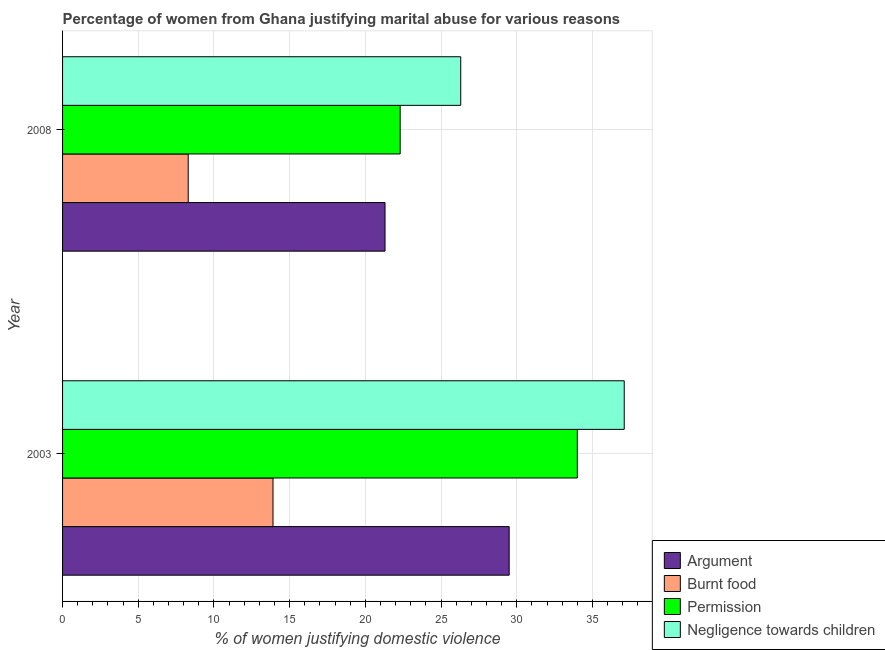How many different coloured bars are there?
Your answer should be compact. 4. How many groups of bars are there?
Provide a succinct answer. 2. Are the number of bars per tick equal to the number of legend labels?
Give a very brief answer. Yes. Are the number of bars on each tick of the Y-axis equal?
Provide a short and direct response. Yes. How many bars are there on the 1st tick from the bottom?
Make the answer very short. 4. In how many cases, is the number of bars for a given year not equal to the number of legend labels?
Offer a very short reply. 0. What is the percentage of women justifying abuse for showing negligence towards children in 2003?
Provide a succinct answer. 37.1. Across all years, what is the maximum percentage of women justifying abuse in the case of an argument?
Make the answer very short. 29.5. Across all years, what is the minimum percentage of women justifying abuse for showing negligence towards children?
Offer a terse response. 26.3. What is the total percentage of women justifying abuse for burning food in the graph?
Give a very brief answer. 22.2. What is the difference between the percentage of women justifying abuse for showing negligence towards children in 2003 and the percentage of women justifying abuse for going without permission in 2008?
Keep it short and to the point. 14.8. What is the average percentage of women justifying abuse for showing negligence towards children per year?
Offer a very short reply. 31.7. In the year 2003, what is the difference between the percentage of women justifying abuse for burning food and percentage of women justifying abuse for going without permission?
Your answer should be compact. -20.1. What is the ratio of the percentage of women justifying abuse for burning food in 2003 to that in 2008?
Offer a terse response. 1.68. What does the 3rd bar from the top in 2003 represents?
Your answer should be very brief. Burnt food. What does the 1st bar from the bottom in 2003 represents?
Your answer should be compact. Argument. How many bars are there?
Offer a very short reply. 8. What is the difference between two consecutive major ticks on the X-axis?
Offer a terse response. 5. Where does the legend appear in the graph?
Your response must be concise. Bottom right. How are the legend labels stacked?
Your response must be concise. Vertical. What is the title of the graph?
Your answer should be compact. Percentage of women from Ghana justifying marital abuse for various reasons. Does "Quality of logistic services" appear as one of the legend labels in the graph?
Keep it short and to the point. No. What is the label or title of the X-axis?
Provide a succinct answer. % of women justifying domestic violence. What is the label or title of the Y-axis?
Make the answer very short. Year. What is the % of women justifying domestic violence of Argument in 2003?
Your answer should be very brief. 29.5. What is the % of women justifying domestic violence in Negligence towards children in 2003?
Your answer should be compact. 37.1. What is the % of women justifying domestic violence in Argument in 2008?
Ensure brevity in your answer.  21.3. What is the % of women justifying domestic violence of Burnt food in 2008?
Provide a short and direct response. 8.3. What is the % of women justifying domestic violence of Permission in 2008?
Your answer should be very brief. 22.3. What is the % of women justifying domestic violence in Negligence towards children in 2008?
Your answer should be compact. 26.3. Across all years, what is the maximum % of women justifying domestic violence in Argument?
Give a very brief answer. 29.5. Across all years, what is the maximum % of women justifying domestic violence in Burnt food?
Provide a short and direct response. 13.9. Across all years, what is the maximum % of women justifying domestic violence in Permission?
Your answer should be compact. 34. Across all years, what is the maximum % of women justifying domestic violence of Negligence towards children?
Your answer should be compact. 37.1. Across all years, what is the minimum % of women justifying domestic violence of Argument?
Ensure brevity in your answer.  21.3. Across all years, what is the minimum % of women justifying domestic violence of Burnt food?
Keep it short and to the point. 8.3. Across all years, what is the minimum % of women justifying domestic violence of Permission?
Your answer should be compact. 22.3. Across all years, what is the minimum % of women justifying domestic violence of Negligence towards children?
Your answer should be compact. 26.3. What is the total % of women justifying domestic violence in Argument in the graph?
Give a very brief answer. 50.8. What is the total % of women justifying domestic violence in Burnt food in the graph?
Your answer should be very brief. 22.2. What is the total % of women justifying domestic violence of Permission in the graph?
Offer a very short reply. 56.3. What is the total % of women justifying domestic violence of Negligence towards children in the graph?
Your answer should be very brief. 63.4. What is the difference between the % of women justifying domestic violence in Burnt food in 2003 and that in 2008?
Your answer should be very brief. 5.6. What is the difference between the % of women justifying domestic violence in Negligence towards children in 2003 and that in 2008?
Offer a very short reply. 10.8. What is the difference between the % of women justifying domestic violence of Argument in 2003 and the % of women justifying domestic violence of Burnt food in 2008?
Provide a short and direct response. 21.2. What is the difference between the % of women justifying domestic violence of Argument in 2003 and the % of women justifying domestic violence of Negligence towards children in 2008?
Provide a short and direct response. 3.2. What is the difference between the % of women justifying domestic violence in Burnt food in 2003 and the % of women justifying domestic violence in Permission in 2008?
Keep it short and to the point. -8.4. What is the difference between the % of women justifying domestic violence of Burnt food in 2003 and the % of women justifying domestic violence of Negligence towards children in 2008?
Make the answer very short. -12.4. What is the difference between the % of women justifying domestic violence in Permission in 2003 and the % of women justifying domestic violence in Negligence towards children in 2008?
Give a very brief answer. 7.7. What is the average % of women justifying domestic violence in Argument per year?
Give a very brief answer. 25.4. What is the average % of women justifying domestic violence of Permission per year?
Provide a succinct answer. 28.15. What is the average % of women justifying domestic violence in Negligence towards children per year?
Keep it short and to the point. 31.7. In the year 2003, what is the difference between the % of women justifying domestic violence of Argument and % of women justifying domestic violence of Burnt food?
Provide a succinct answer. 15.6. In the year 2003, what is the difference between the % of women justifying domestic violence in Burnt food and % of women justifying domestic violence in Permission?
Your answer should be compact. -20.1. In the year 2003, what is the difference between the % of women justifying domestic violence of Burnt food and % of women justifying domestic violence of Negligence towards children?
Your answer should be very brief. -23.2. In the year 2003, what is the difference between the % of women justifying domestic violence of Permission and % of women justifying domestic violence of Negligence towards children?
Give a very brief answer. -3.1. In the year 2008, what is the difference between the % of women justifying domestic violence of Argument and % of women justifying domestic violence of Permission?
Keep it short and to the point. -1. In the year 2008, what is the difference between the % of women justifying domestic violence of Argument and % of women justifying domestic violence of Negligence towards children?
Offer a terse response. -5. In the year 2008, what is the difference between the % of women justifying domestic violence in Burnt food and % of women justifying domestic violence in Permission?
Provide a short and direct response. -14. In the year 2008, what is the difference between the % of women justifying domestic violence of Burnt food and % of women justifying domestic violence of Negligence towards children?
Your response must be concise. -18. What is the ratio of the % of women justifying domestic violence of Argument in 2003 to that in 2008?
Offer a terse response. 1.39. What is the ratio of the % of women justifying domestic violence in Burnt food in 2003 to that in 2008?
Keep it short and to the point. 1.67. What is the ratio of the % of women justifying domestic violence of Permission in 2003 to that in 2008?
Provide a succinct answer. 1.52. What is the ratio of the % of women justifying domestic violence in Negligence towards children in 2003 to that in 2008?
Provide a succinct answer. 1.41. What is the difference between the highest and the second highest % of women justifying domestic violence in Argument?
Keep it short and to the point. 8.2. What is the difference between the highest and the second highest % of women justifying domestic violence in Burnt food?
Provide a short and direct response. 5.6. What is the difference between the highest and the second highest % of women justifying domestic violence in Negligence towards children?
Your answer should be very brief. 10.8. What is the difference between the highest and the lowest % of women justifying domestic violence of Permission?
Provide a short and direct response. 11.7. 